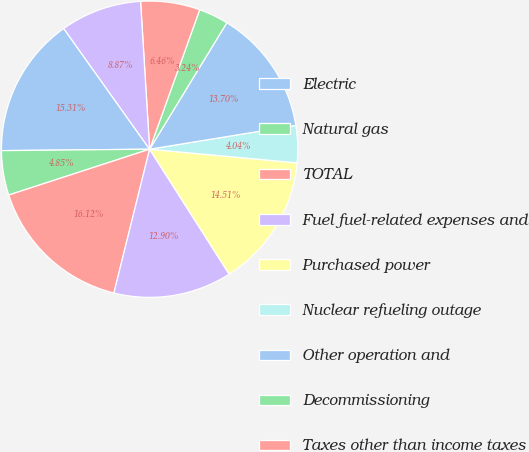Convert chart to OTSL. <chart><loc_0><loc_0><loc_500><loc_500><pie_chart><fcel>Electric<fcel>Natural gas<fcel>TOTAL<fcel>Fuel fuel-related expenses and<fcel>Purchased power<fcel>Nuclear refueling outage<fcel>Other operation and<fcel>Decommissioning<fcel>Taxes other than income taxes<fcel>Depreciation and amortization<nl><fcel>15.31%<fcel>4.85%<fcel>16.12%<fcel>12.9%<fcel>14.51%<fcel>4.04%<fcel>13.7%<fcel>3.24%<fcel>6.46%<fcel>8.87%<nl></chart> 